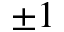<formula> <loc_0><loc_0><loc_500><loc_500>\pm 1</formula> 